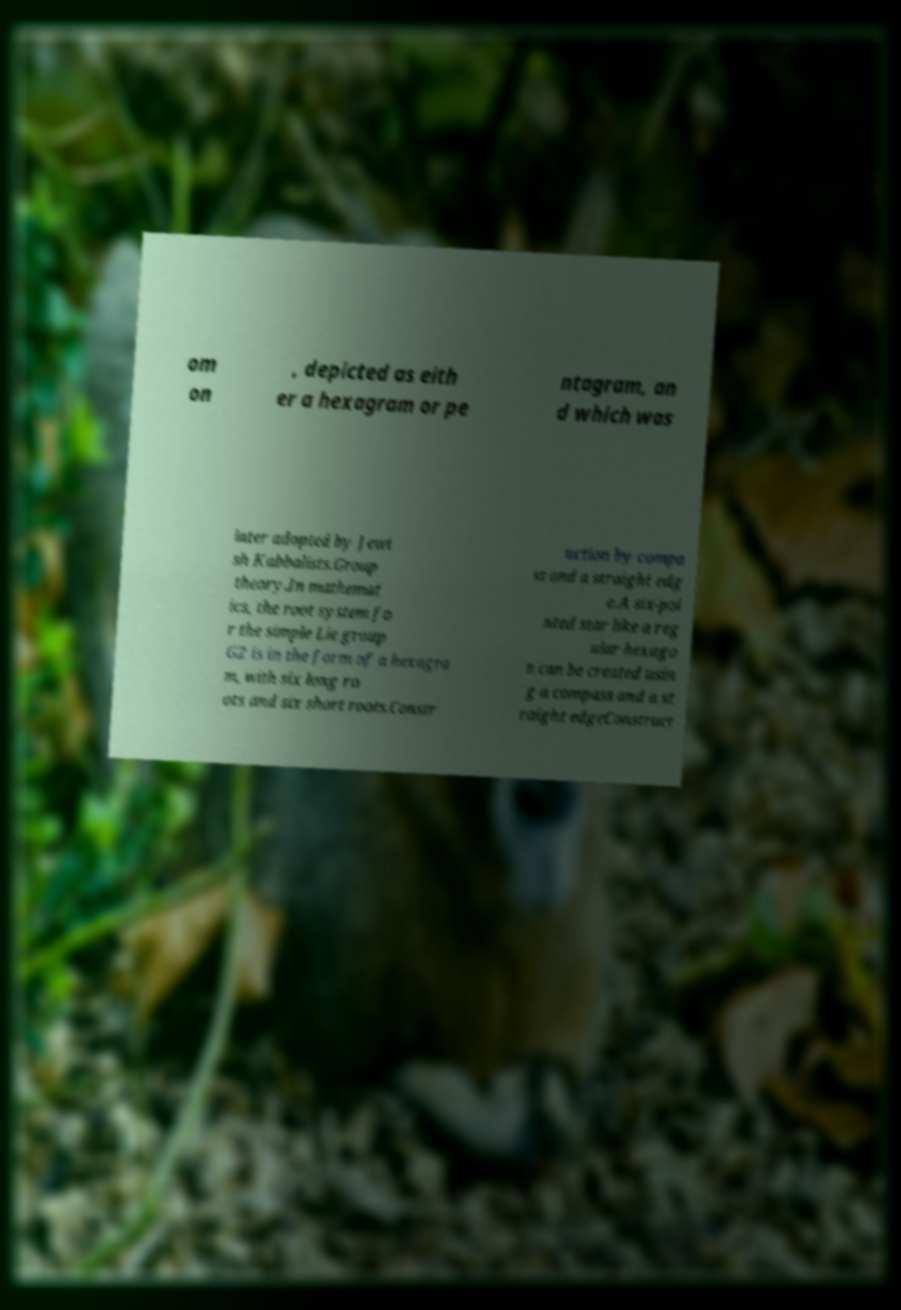Can you read and provide the text displayed in the image?This photo seems to have some interesting text. Can you extract and type it out for me? om on , depicted as eith er a hexagram or pe ntagram, an d which was later adopted by Jewi sh Kabbalists.Group theory.In mathemat ics, the root system fo r the simple Lie group G2 is in the form of a hexagra m, with six long ro ots and six short roots.Constr uction by compa ss and a straight edg e.A six-poi nted star like a reg ular hexago n can be created usin g a compass and a st raight edgeConstruct 